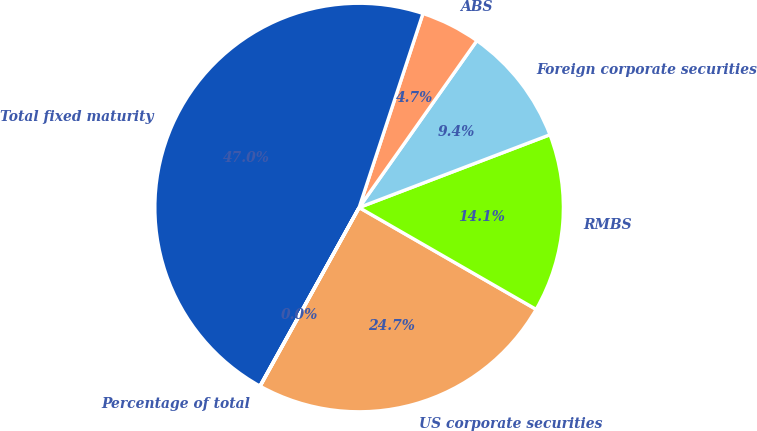Convert chart. <chart><loc_0><loc_0><loc_500><loc_500><pie_chart><fcel>US corporate securities<fcel>RMBS<fcel>Foreign corporate securities<fcel>ABS<fcel>Total fixed maturity<fcel>Percentage of total<nl><fcel>24.74%<fcel>14.11%<fcel>9.42%<fcel>4.72%<fcel>46.99%<fcel>0.02%<nl></chart> 